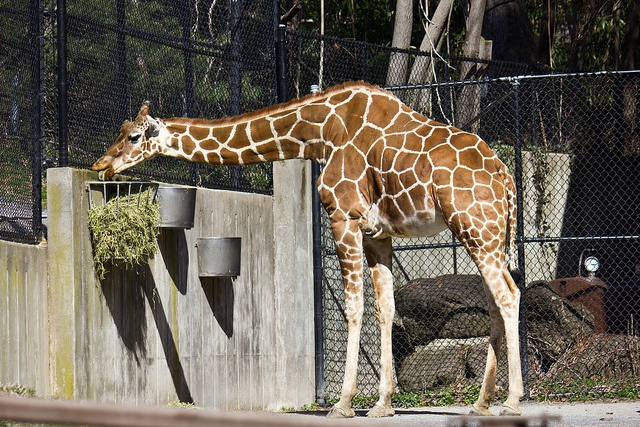Describe the objects in this image and their specific colors. I can see a giraffe in black, ivory, brown, gray, and maroon tones in this image. 